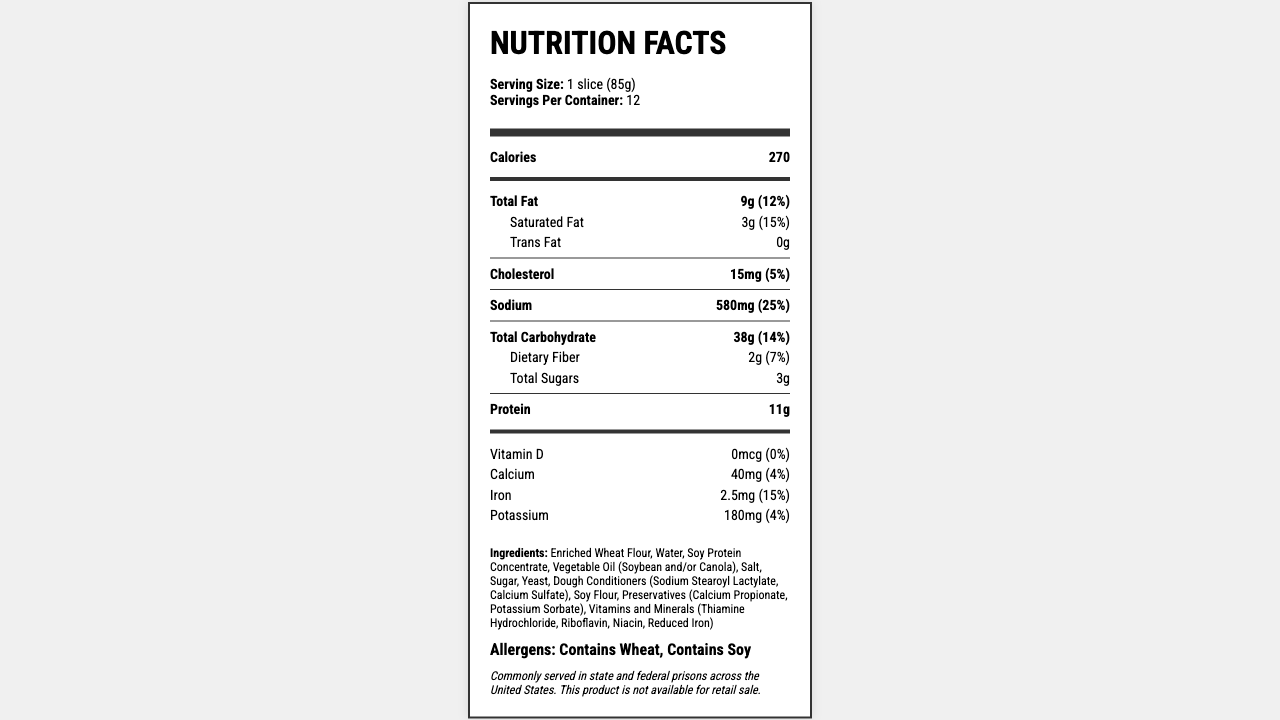what is the serving size? The serving size is indicated at the top of the label in the serving info section.
Answer: 1 slice (85g) how many servings are there per container? The number of servings per container is listed in the serving info section at the top of the label.
Answer: 12 what is the total calorie count per serving? The calorie count per serving is prominently displayed in the main nutrient section.
Answer: 270 how much total fat is in one serving? The amount of total fat per serving is found in the total fat row in the main nutrient section.
Answer: 9g what are the ingredients in Prison Loaf? The ingredients are listed in the ingredients section towards the bottom of the label.
Answer: Enriched Wheat Flour, Water, Soy Protein Concentrate, Vegetable Oil (Soybean and/or Canola), Salt, Sugar, Yeast, Dough Conditioners (Sodium Stearoyl Lactylate, Calcium Sulfate), Soy Flour, Preservatives (Calcium Propionate, Potassium Sorbate), Vitamins and Minerals (Thiamine Hydrochloride, Riboflavin, Niacin, Reduced Iron) how much sodium is in one serving? A. 380 mg B. 480 mg C. 580 mg D. 680 mg The amount of sodium per serving is listed in the main nutrient section.
Answer: C. 580 mg how much protein does one serving contain? The protein content per serving can be found in the main nutrient section.
Answer: 11g what percentage of the daily value is the saturated fat content? A. 5% B. 10% C. 15% D. 20% The percentage of the daily value for saturated fat is listed next to the amount of saturated fat in the sub-nutrient section under total fat.
Answer: C. 15% is there any trans fat in the Prison Loaf? The trans fat amount is listed as 0g in the sub-nutrient section under total fat, suggesting there is no trans fat.
Answer: No summarize the primary nutritional information of this product. The summary captures key details like the amount of calories, fat, cholesterol, sodium, carbohydrates, fiber, sugar, and protein per serving, as well as the daily value percentages for each.
Answer: Prison Loaf has 270 calories per serving (1 slice, 85g). It contains 9g of total fat (15% DV), 3g of saturated fat (15% DV), 0g of trans fat, 15mg of cholesterol (5% DV), 580mg of sodium (25% DV), 38g of carbohydrates (14% DV), 2g of dietary fiber (7% DV), 3g of total sugars, and 11g of protein. It has no Vitamin D, 40mg of calcium (4% DV), 2.5mg of iron (15% DV), and 180mg of potassium (4% DV). where is this product commonly served? The additional info section at the bottom of the label mentions where the product is commonly served.
Answer: State and federal prisons across the United States who is the manufacturer of the Prison Loaf? The manufacturer's name is listed at the bottom of the label in the additional info section.
Answer: Aramark Correctional Services how much dietary fiber is in one serving of Prison Loaf? The dietary fiber content per serving is located in the sub-nutrient section under total carbohydrates.
Answer: 2g what is the daily value percentage of iron in one serving? The daily value percentage of iron is listed next to its amount in the vitamin and mineral section.
Answer: 15% how much potassium is in one serving? The amount of potassium per serving is found in the vitamin and mineral section.
Answer: 180mg how does the document illustrate the nutritional information? The method of illustrating the document (e.g., using HTML and CSS with a custom font) is not included in the visual content of the document.
Answer: Cannot be determined is this product available for retail sale? The additional info section at the bottom of the label specifies that the product is not available for retail sale.
Answer: No 